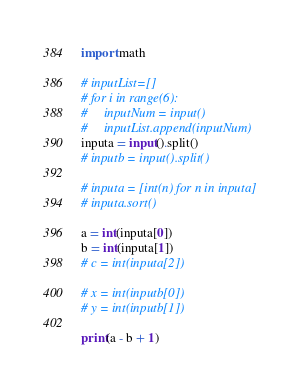Convert code to text. <code><loc_0><loc_0><loc_500><loc_500><_Python_>import math

# inputList=[]
# for i in range(6):
#     inputNum = input()
#     inputList.append(inputNum)
inputa = input().split()
# inputb = input().split()

# inputa = [int(n) for n in inputa]
# inputa.sort()

a = int(inputa[0])
b = int(inputa[1])
# c = int(inputa[2])

# x = int(inputb[0])
# y = int(inputb[1])

print(a - b + 1)</code> 